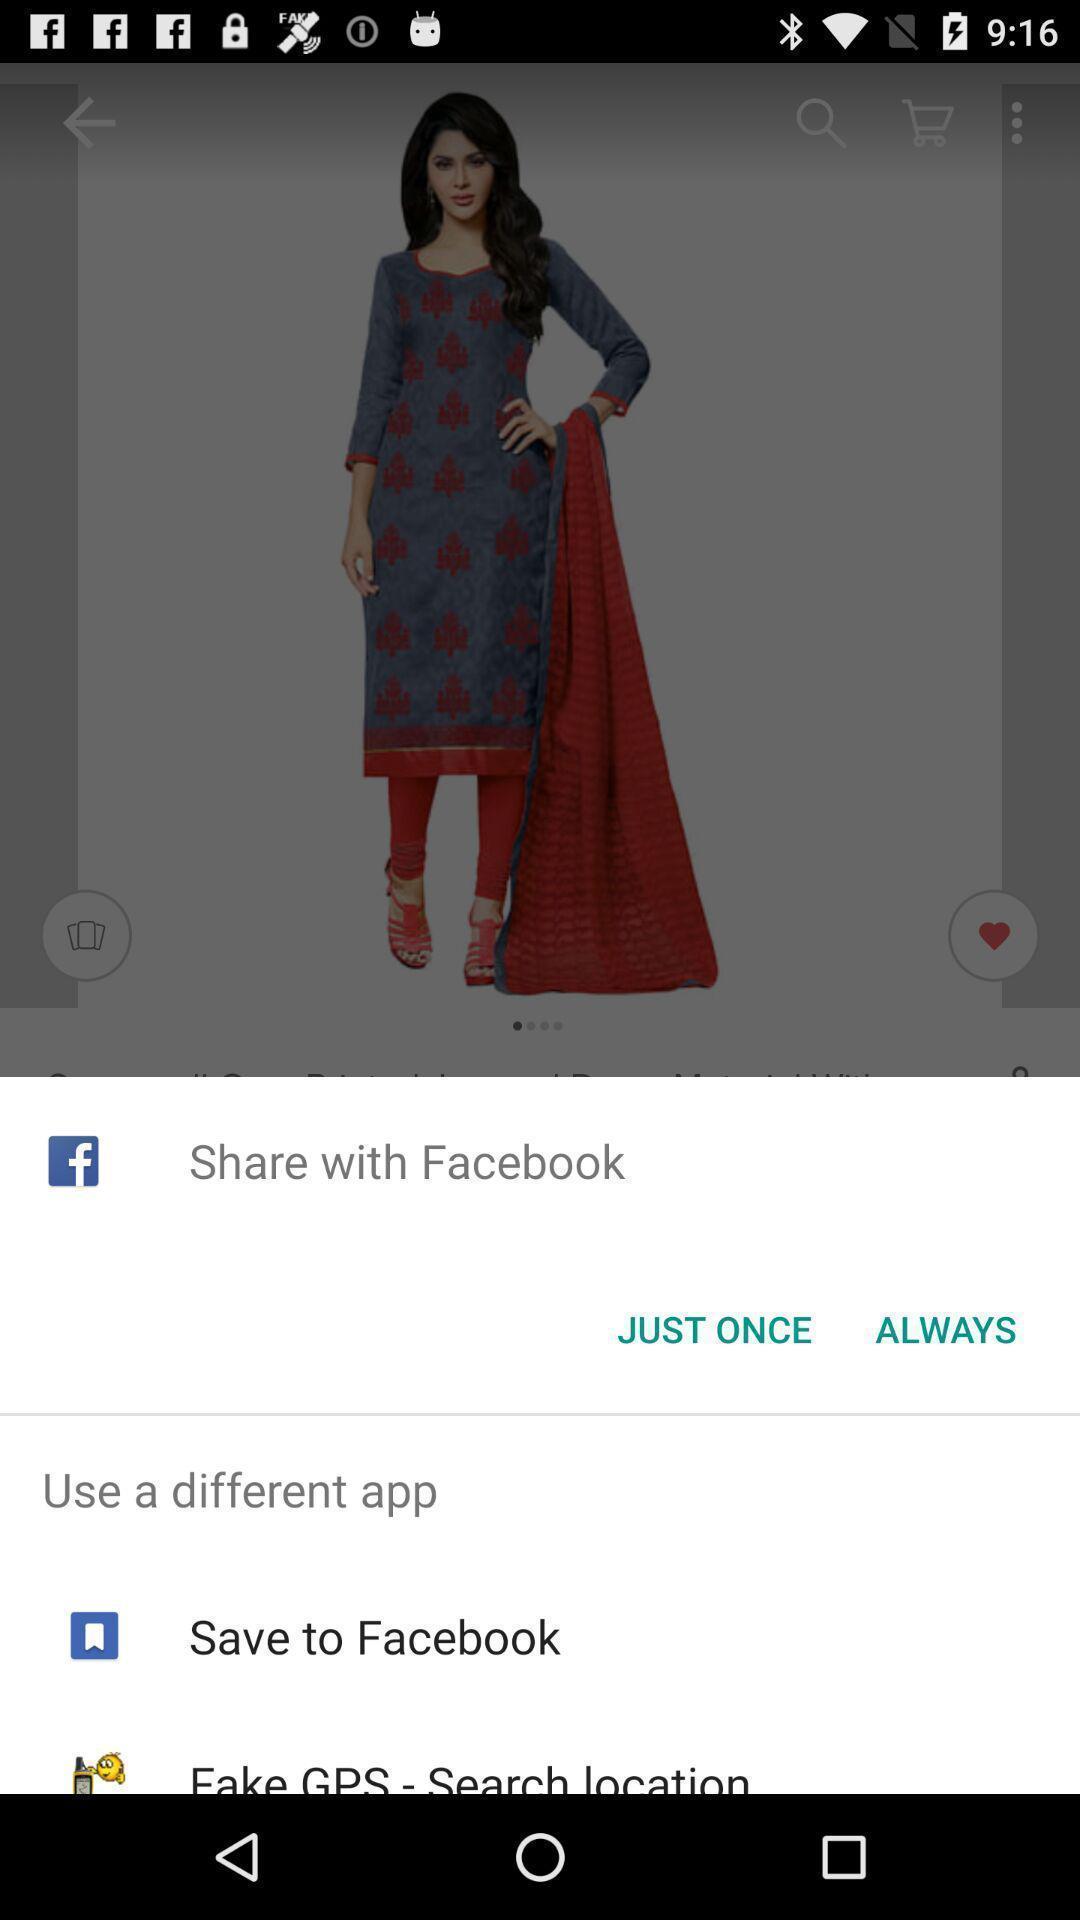Describe this image in words. Pop up showing an option to share with an app. 